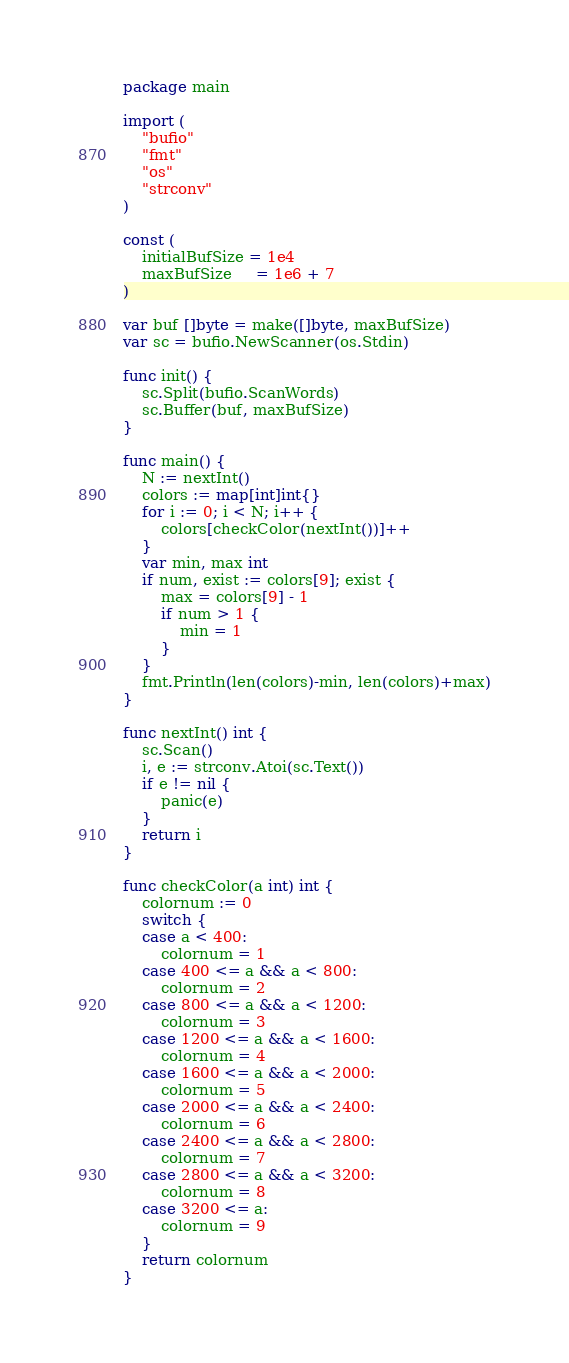Convert code to text. <code><loc_0><loc_0><loc_500><loc_500><_Go_>package main

import (
	"bufio"
	"fmt"
	"os"
	"strconv"
)

const (
	initialBufSize = 1e4
	maxBufSize     = 1e6 + 7
)

var buf []byte = make([]byte, maxBufSize)
var sc = bufio.NewScanner(os.Stdin)

func init() {
	sc.Split(bufio.ScanWords)
	sc.Buffer(buf, maxBufSize)
}

func main() {
	N := nextInt()
	colors := map[int]int{}
	for i := 0; i < N; i++ {
		colors[checkColor(nextInt())]++
	}
	var min, max int
	if num, exist := colors[9]; exist {
		max = colors[9] - 1
		if num > 1 {
			min = 1
		}
	}
	fmt.Println(len(colors)-min, len(colors)+max)
}

func nextInt() int {
	sc.Scan()
	i, e := strconv.Atoi(sc.Text())
	if e != nil {
		panic(e)
	}
	return i
}

func checkColor(a int) int {
	colornum := 0
	switch {
	case a < 400:
		colornum = 1
	case 400 <= a && a < 800:
		colornum = 2
	case 800 <= a && a < 1200:
		colornum = 3
	case 1200 <= a && a < 1600:
		colornum = 4
	case 1600 <= a && a < 2000:
		colornum = 5
	case 2000 <= a && a < 2400:
		colornum = 6
	case 2400 <= a && a < 2800:
		colornum = 7
	case 2800 <= a && a < 3200:
		colornum = 8
	case 3200 <= a:
		colornum = 9
	}
	return colornum
}
</code> 